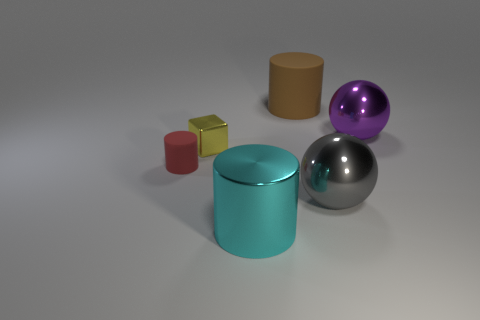Is there any other thing of the same color as the small cube?
Your answer should be very brief. No. What number of shiny objects are both behind the cyan object and in front of the yellow block?
Offer a terse response. 1. Does the rubber object behind the small cube have the same size as the shiny object that is to the left of the big cyan thing?
Your answer should be compact. No. How many objects are either shiny objects left of the big brown thing or big gray metallic balls?
Offer a very short reply. 3. There is a large cylinder that is on the right side of the large cyan metallic object; what material is it?
Provide a succinct answer. Rubber. What is the material of the small red cylinder?
Give a very brief answer. Rubber. What is the material of the big cyan cylinder left of the large metal thing that is behind the large ball in front of the red rubber object?
Your answer should be compact. Metal. Are there any other things that are the same material as the red object?
Provide a short and direct response. Yes. Is the size of the brown rubber thing the same as the rubber cylinder in front of the cube?
Your response must be concise. No. What number of objects are either big metallic things on the left side of the large gray thing or metallic objects right of the brown object?
Your answer should be compact. 3. 